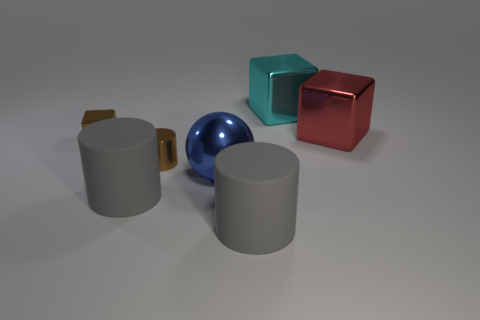Subtract all purple balls. Subtract all yellow cylinders. How many balls are left? 1 Subtract all yellow cylinders. How many gray spheres are left? 0 Add 1 small cyans. How many reds exist? 0 Subtract all small gray metallic balls. Subtract all balls. How many objects are left? 6 Add 2 cyan shiny things. How many cyan shiny things are left? 3 Add 3 rubber things. How many rubber things exist? 5 Add 3 cyan things. How many objects exist? 10 Subtract all brown cylinders. How many cylinders are left? 2 Subtract all brown shiny cylinders. How many cylinders are left? 2 Subtract 0 gray blocks. How many objects are left? 7 